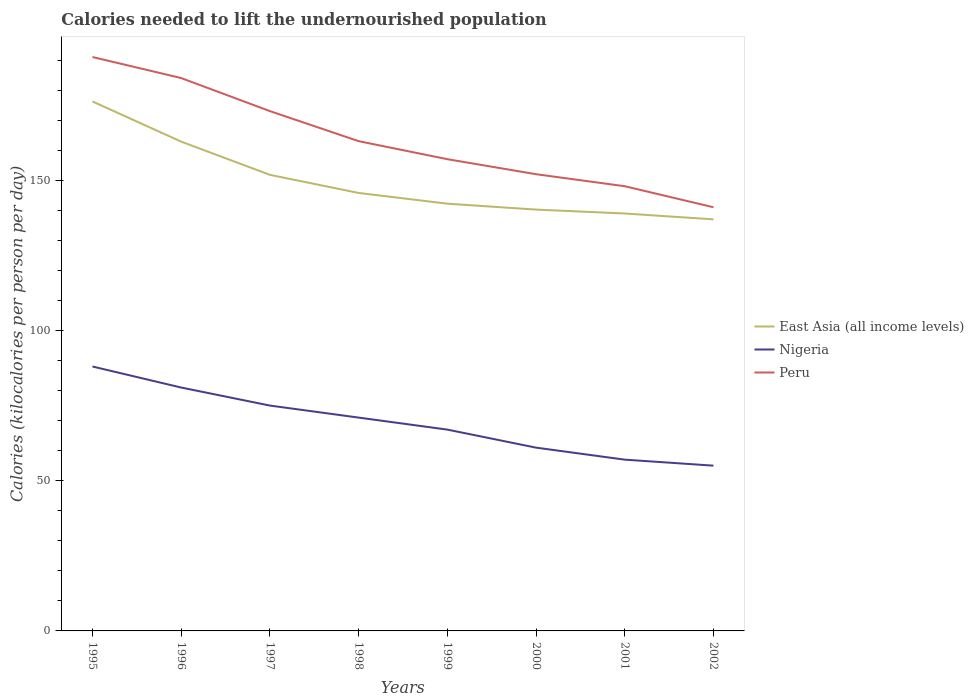How many different coloured lines are there?
Your answer should be compact. 3. Does the line corresponding to Peru intersect with the line corresponding to East Asia (all income levels)?
Provide a short and direct response. No. Across all years, what is the maximum total calories needed to lift the undernourished population in East Asia (all income levels)?
Keep it short and to the point. 136.97. What is the total total calories needed to lift the undernourished population in East Asia (all income levels) in the graph?
Your answer should be very brief. 3.25. What is the difference between the highest and the second highest total calories needed to lift the undernourished population in Nigeria?
Make the answer very short. 33. Is the total calories needed to lift the undernourished population in Nigeria strictly greater than the total calories needed to lift the undernourished population in East Asia (all income levels) over the years?
Offer a terse response. Yes. How many lines are there?
Your response must be concise. 3. How many years are there in the graph?
Make the answer very short. 8. Are the values on the major ticks of Y-axis written in scientific E-notation?
Provide a succinct answer. No. Does the graph contain grids?
Provide a short and direct response. No. How many legend labels are there?
Provide a short and direct response. 3. How are the legend labels stacked?
Provide a succinct answer. Vertical. What is the title of the graph?
Provide a short and direct response. Calories needed to lift the undernourished population. Does "Yemen, Rep." appear as one of the legend labels in the graph?
Your answer should be very brief. No. What is the label or title of the X-axis?
Keep it short and to the point. Years. What is the label or title of the Y-axis?
Give a very brief answer. Calories (kilocalories per person per day). What is the Calories (kilocalories per person per day) of East Asia (all income levels) in 1995?
Ensure brevity in your answer.  176.22. What is the Calories (kilocalories per person per day) in Peru in 1995?
Give a very brief answer. 191. What is the Calories (kilocalories per person per day) of East Asia (all income levels) in 1996?
Offer a terse response. 162.84. What is the Calories (kilocalories per person per day) of Nigeria in 1996?
Offer a very short reply. 81. What is the Calories (kilocalories per person per day) of Peru in 1996?
Provide a succinct answer. 184. What is the Calories (kilocalories per person per day) in East Asia (all income levels) in 1997?
Your answer should be very brief. 151.79. What is the Calories (kilocalories per person per day) in Nigeria in 1997?
Make the answer very short. 75. What is the Calories (kilocalories per person per day) in Peru in 1997?
Make the answer very short. 173. What is the Calories (kilocalories per person per day) of East Asia (all income levels) in 1998?
Provide a succinct answer. 145.76. What is the Calories (kilocalories per person per day) of Nigeria in 1998?
Your answer should be very brief. 71. What is the Calories (kilocalories per person per day) of Peru in 1998?
Your answer should be compact. 163. What is the Calories (kilocalories per person per day) of East Asia (all income levels) in 1999?
Give a very brief answer. 142.19. What is the Calories (kilocalories per person per day) of Peru in 1999?
Your answer should be very brief. 157. What is the Calories (kilocalories per person per day) of East Asia (all income levels) in 2000?
Offer a very short reply. 140.22. What is the Calories (kilocalories per person per day) in Nigeria in 2000?
Ensure brevity in your answer.  61. What is the Calories (kilocalories per person per day) of Peru in 2000?
Give a very brief answer. 152. What is the Calories (kilocalories per person per day) in East Asia (all income levels) in 2001?
Give a very brief answer. 138.92. What is the Calories (kilocalories per person per day) in Nigeria in 2001?
Offer a terse response. 57. What is the Calories (kilocalories per person per day) of Peru in 2001?
Make the answer very short. 148. What is the Calories (kilocalories per person per day) in East Asia (all income levels) in 2002?
Offer a very short reply. 136.97. What is the Calories (kilocalories per person per day) in Nigeria in 2002?
Provide a succinct answer. 55. What is the Calories (kilocalories per person per day) in Peru in 2002?
Offer a terse response. 141. Across all years, what is the maximum Calories (kilocalories per person per day) of East Asia (all income levels)?
Keep it short and to the point. 176.22. Across all years, what is the maximum Calories (kilocalories per person per day) in Peru?
Ensure brevity in your answer.  191. Across all years, what is the minimum Calories (kilocalories per person per day) in East Asia (all income levels)?
Provide a succinct answer. 136.97. Across all years, what is the minimum Calories (kilocalories per person per day) of Nigeria?
Provide a succinct answer. 55. Across all years, what is the minimum Calories (kilocalories per person per day) in Peru?
Your answer should be compact. 141. What is the total Calories (kilocalories per person per day) of East Asia (all income levels) in the graph?
Your answer should be compact. 1194.91. What is the total Calories (kilocalories per person per day) in Nigeria in the graph?
Offer a terse response. 555. What is the total Calories (kilocalories per person per day) of Peru in the graph?
Provide a short and direct response. 1309. What is the difference between the Calories (kilocalories per person per day) in East Asia (all income levels) in 1995 and that in 1996?
Make the answer very short. 13.38. What is the difference between the Calories (kilocalories per person per day) in Nigeria in 1995 and that in 1996?
Provide a succinct answer. 7. What is the difference between the Calories (kilocalories per person per day) of Peru in 1995 and that in 1996?
Make the answer very short. 7. What is the difference between the Calories (kilocalories per person per day) of East Asia (all income levels) in 1995 and that in 1997?
Your response must be concise. 24.43. What is the difference between the Calories (kilocalories per person per day) of East Asia (all income levels) in 1995 and that in 1998?
Offer a very short reply. 30.46. What is the difference between the Calories (kilocalories per person per day) of East Asia (all income levels) in 1995 and that in 1999?
Your answer should be very brief. 34.03. What is the difference between the Calories (kilocalories per person per day) in Nigeria in 1995 and that in 1999?
Your answer should be compact. 21. What is the difference between the Calories (kilocalories per person per day) of Peru in 1995 and that in 1999?
Keep it short and to the point. 34. What is the difference between the Calories (kilocalories per person per day) in East Asia (all income levels) in 1995 and that in 2000?
Keep it short and to the point. 36. What is the difference between the Calories (kilocalories per person per day) of Nigeria in 1995 and that in 2000?
Make the answer very short. 27. What is the difference between the Calories (kilocalories per person per day) of East Asia (all income levels) in 1995 and that in 2001?
Offer a very short reply. 37.29. What is the difference between the Calories (kilocalories per person per day) in Peru in 1995 and that in 2001?
Provide a succinct answer. 43. What is the difference between the Calories (kilocalories per person per day) of East Asia (all income levels) in 1995 and that in 2002?
Provide a succinct answer. 39.25. What is the difference between the Calories (kilocalories per person per day) of Nigeria in 1995 and that in 2002?
Provide a short and direct response. 33. What is the difference between the Calories (kilocalories per person per day) in Peru in 1995 and that in 2002?
Make the answer very short. 50. What is the difference between the Calories (kilocalories per person per day) in East Asia (all income levels) in 1996 and that in 1997?
Offer a terse response. 11.05. What is the difference between the Calories (kilocalories per person per day) of Nigeria in 1996 and that in 1997?
Provide a succinct answer. 6. What is the difference between the Calories (kilocalories per person per day) of Peru in 1996 and that in 1997?
Offer a very short reply. 11. What is the difference between the Calories (kilocalories per person per day) in East Asia (all income levels) in 1996 and that in 1998?
Offer a terse response. 17.08. What is the difference between the Calories (kilocalories per person per day) of East Asia (all income levels) in 1996 and that in 1999?
Provide a succinct answer. 20.65. What is the difference between the Calories (kilocalories per person per day) in Nigeria in 1996 and that in 1999?
Keep it short and to the point. 14. What is the difference between the Calories (kilocalories per person per day) in East Asia (all income levels) in 1996 and that in 2000?
Make the answer very short. 22.62. What is the difference between the Calories (kilocalories per person per day) of Nigeria in 1996 and that in 2000?
Your answer should be very brief. 20. What is the difference between the Calories (kilocalories per person per day) of East Asia (all income levels) in 1996 and that in 2001?
Your answer should be compact. 23.92. What is the difference between the Calories (kilocalories per person per day) of Peru in 1996 and that in 2001?
Provide a short and direct response. 36. What is the difference between the Calories (kilocalories per person per day) of East Asia (all income levels) in 1996 and that in 2002?
Your answer should be very brief. 25.87. What is the difference between the Calories (kilocalories per person per day) of East Asia (all income levels) in 1997 and that in 1998?
Make the answer very short. 6.03. What is the difference between the Calories (kilocalories per person per day) of Nigeria in 1997 and that in 1998?
Your response must be concise. 4. What is the difference between the Calories (kilocalories per person per day) in Peru in 1997 and that in 1998?
Offer a terse response. 10. What is the difference between the Calories (kilocalories per person per day) of East Asia (all income levels) in 1997 and that in 1999?
Your answer should be compact. 9.6. What is the difference between the Calories (kilocalories per person per day) in Nigeria in 1997 and that in 1999?
Your answer should be very brief. 8. What is the difference between the Calories (kilocalories per person per day) in Peru in 1997 and that in 1999?
Offer a very short reply. 16. What is the difference between the Calories (kilocalories per person per day) in East Asia (all income levels) in 1997 and that in 2000?
Keep it short and to the point. 11.57. What is the difference between the Calories (kilocalories per person per day) of Nigeria in 1997 and that in 2000?
Offer a terse response. 14. What is the difference between the Calories (kilocalories per person per day) in Peru in 1997 and that in 2000?
Your answer should be compact. 21. What is the difference between the Calories (kilocalories per person per day) in East Asia (all income levels) in 1997 and that in 2001?
Offer a terse response. 12.86. What is the difference between the Calories (kilocalories per person per day) of East Asia (all income levels) in 1997 and that in 2002?
Your answer should be very brief. 14.82. What is the difference between the Calories (kilocalories per person per day) in Nigeria in 1997 and that in 2002?
Provide a succinct answer. 20. What is the difference between the Calories (kilocalories per person per day) of East Asia (all income levels) in 1998 and that in 1999?
Provide a succinct answer. 3.57. What is the difference between the Calories (kilocalories per person per day) in Peru in 1998 and that in 1999?
Ensure brevity in your answer.  6. What is the difference between the Calories (kilocalories per person per day) in East Asia (all income levels) in 1998 and that in 2000?
Make the answer very short. 5.54. What is the difference between the Calories (kilocalories per person per day) in East Asia (all income levels) in 1998 and that in 2001?
Your response must be concise. 6.83. What is the difference between the Calories (kilocalories per person per day) in East Asia (all income levels) in 1998 and that in 2002?
Provide a short and direct response. 8.79. What is the difference between the Calories (kilocalories per person per day) of East Asia (all income levels) in 1999 and that in 2000?
Offer a terse response. 1.97. What is the difference between the Calories (kilocalories per person per day) of Nigeria in 1999 and that in 2000?
Your answer should be very brief. 6. What is the difference between the Calories (kilocalories per person per day) of Peru in 1999 and that in 2000?
Your answer should be compact. 5. What is the difference between the Calories (kilocalories per person per day) in East Asia (all income levels) in 1999 and that in 2001?
Make the answer very short. 3.27. What is the difference between the Calories (kilocalories per person per day) of Nigeria in 1999 and that in 2001?
Provide a succinct answer. 10. What is the difference between the Calories (kilocalories per person per day) in East Asia (all income levels) in 1999 and that in 2002?
Your answer should be very brief. 5.22. What is the difference between the Calories (kilocalories per person per day) in East Asia (all income levels) in 2000 and that in 2001?
Your response must be concise. 1.29. What is the difference between the Calories (kilocalories per person per day) in Peru in 2000 and that in 2001?
Offer a very short reply. 4. What is the difference between the Calories (kilocalories per person per day) of East Asia (all income levels) in 2000 and that in 2002?
Keep it short and to the point. 3.25. What is the difference between the Calories (kilocalories per person per day) in East Asia (all income levels) in 2001 and that in 2002?
Offer a very short reply. 1.95. What is the difference between the Calories (kilocalories per person per day) in East Asia (all income levels) in 1995 and the Calories (kilocalories per person per day) in Nigeria in 1996?
Make the answer very short. 95.22. What is the difference between the Calories (kilocalories per person per day) in East Asia (all income levels) in 1995 and the Calories (kilocalories per person per day) in Peru in 1996?
Offer a terse response. -7.78. What is the difference between the Calories (kilocalories per person per day) in Nigeria in 1995 and the Calories (kilocalories per person per day) in Peru in 1996?
Ensure brevity in your answer.  -96. What is the difference between the Calories (kilocalories per person per day) of East Asia (all income levels) in 1995 and the Calories (kilocalories per person per day) of Nigeria in 1997?
Give a very brief answer. 101.22. What is the difference between the Calories (kilocalories per person per day) in East Asia (all income levels) in 1995 and the Calories (kilocalories per person per day) in Peru in 1997?
Keep it short and to the point. 3.22. What is the difference between the Calories (kilocalories per person per day) in Nigeria in 1995 and the Calories (kilocalories per person per day) in Peru in 1997?
Provide a succinct answer. -85. What is the difference between the Calories (kilocalories per person per day) of East Asia (all income levels) in 1995 and the Calories (kilocalories per person per day) of Nigeria in 1998?
Your response must be concise. 105.22. What is the difference between the Calories (kilocalories per person per day) of East Asia (all income levels) in 1995 and the Calories (kilocalories per person per day) of Peru in 1998?
Give a very brief answer. 13.22. What is the difference between the Calories (kilocalories per person per day) in Nigeria in 1995 and the Calories (kilocalories per person per day) in Peru in 1998?
Offer a terse response. -75. What is the difference between the Calories (kilocalories per person per day) of East Asia (all income levels) in 1995 and the Calories (kilocalories per person per day) of Nigeria in 1999?
Your answer should be very brief. 109.22. What is the difference between the Calories (kilocalories per person per day) of East Asia (all income levels) in 1995 and the Calories (kilocalories per person per day) of Peru in 1999?
Offer a very short reply. 19.22. What is the difference between the Calories (kilocalories per person per day) of Nigeria in 1995 and the Calories (kilocalories per person per day) of Peru in 1999?
Offer a terse response. -69. What is the difference between the Calories (kilocalories per person per day) of East Asia (all income levels) in 1995 and the Calories (kilocalories per person per day) of Nigeria in 2000?
Your answer should be very brief. 115.22. What is the difference between the Calories (kilocalories per person per day) in East Asia (all income levels) in 1995 and the Calories (kilocalories per person per day) in Peru in 2000?
Provide a succinct answer. 24.22. What is the difference between the Calories (kilocalories per person per day) in Nigeria in 1995 and the Calories (kilocalories per person per day) in Peru in 2000?
Provide a short and direct response. -64. What is the difference between the Calories (kilocalories per person per day) of East Asia (all income levels) in 1995 and the Calories (kilocalories per person per day) of Nigeria in 2001?
Your answer should be compact. 119.22. What is the difference between the Calories (kilocalories per person per day) of East Asia (all income levels) in 1995 and the Calories (kilocalories per person per day) of Peru in 2001?
Keep it short and to the point. 28.22. What is the difference between the Calories (kilocalories per person per day) of Nigeria in 1995 and the Calories (kilocalories per person per day) of Peru in 2001?
Ensure brevity in your answer.  -60. What is the difference between the Calories (kilocalories per person per day) in East Asia (all income levels) in 1995 and the Calories (kilocalories per person per day) in Nigeria in 2002?
Keep it short and to the point. 121.22. What is the difference between the Calories (kilocalories per person per day) of East Asia (all income levels) in 1995 and the Calories (kilocalories per person per day) of Peru in 2002?
Offer a very short reply. 35.22. What is the difference between the Calories (kilocalories per person per day) of Nigeria in 1995 and the Calories (kilocalories per person per day) of Peru in 2002?
Provide a succinct answer. -53. What is the difference between the Calories (kilocalories per person per day) in East Asia (all income levels) in 1996 and the Calories (kilocalories per person per day) in Nigeria in 1997?
Your response must be concise. 87.84. What is the difference between the Calories (kilocalories per person per day) in East Asia (all income levels) in 1996 and the Calories (kilocalories per person per day) in Peru in 1997?
Offer a very short reply. -10.16. What is the difference between the Calories (kilocalories per person per day) in Nigeria in 1996 and the Calories (kilocalories per person per day) in Peru in 1997?
Provide a short and direct response. -92. What is the difference between the Calories (kilocalories per person per day) of East Asia (all income levels) in 1996 and the Calories (kilocalories per person per day) of Nigeria in 1998?
Offer a terse response. 91.84. What is the difference between the Calories (kilocalories per person per day) in East Asia (all income levels) in 1996 and the Calories (kilocalories per person per day) in Peru in 1998?
Provide a short and direct response. -0.16. What is the difference between the Calories (kilocalories per person per day) of Nigeria in 1996 and the Calories (kilocalories per person per day) of Peru in 1998?
Your answer should be very brief. -82. What is the difference between the Calories (kilocalories per person per day) in East Asia (all income levels) in 1996 and the Calories (kilocalories per person per day) in Nigeria in 1999?
Your answer should be compact. 95.84. What is the difference between the Calories (kilocalories per person per day) in East Asia (all income levels) in 1996 and the Calories (kilocalories per person per day) in Peru in 1999?
Provide a short and direct response. 5.84. What is the difference between the Calories (kilocalories per person per day) in Nigeria in 1996 and the Calories (kilocalories per person per day) in Peru in 1999?
Your answer should be compact. -76. What is the difference between the Calories (kilocalories per person per day) in East Asia (all income levels) in 1996 and the Calories (kilocalories per person per day) in Nigeria in 2000?
Give a very brief answer. 101.84. What is the difference between the Calories (kilocalories per person per day) in East Asia (all income levels) in 1996 and the Calories (kilocalories per person per day) in Peru in 2000?
Ensure brevity in your answer.  10.84. What is the difference between the Calories (kilocalories per person per day) of Nigeria in 1996 and the Calories (kilocalories per person per day) of Peru in 2000?
Your answer should be very brief. -71. What is the difference between the Calories (kilocalories per person per day) in East Asia (all income levels) in 1996 and the Calories (kilocalories per person per day) in Nigeria in 2001?
Your answer should be very brief. 105.84. What is the difference between the Calories (kilocalories per person per day) of East Asia (all income levels) in 1996 and the Calories (kilocalories per person per day) of Peru in 2001?
Offer a very short reply. 14.84. What is the difference between the Calories (kilocalories per person per day) of Nigeria in 1996 and the Calories (kilocalories per person per day) of Peru in 2001?
Your answer should be very brief. -67. What is the difference between the Calories (kilocalories per person per day) of East Asia (all income levels) in 1996 and the Calories (kilocalories per person per day) of Nigeria in 2002?
Keep it short and to the point. 107.84. What is the difference between the Calories (kilocalories per person per day) in East Asia (all income levels) in 1996 and the Calories (kilocalories per person per day) in Peru in 2002?
Provide a short and direct response. 21.84. What is the difference between the Calories (kilocalories per person per day) of Nigeria in 1996 and the Calories (kilocalories per person per day) of Peru in 2002?
Give a very brief answer. -60. What is the difference between the Calories (kilocalories per person per day) in East Asia (all income levels) in 1997 and the Calories (kilocalories per person per day) in Nigeria in 1998?
Make the answer very short. 80.79. What is the difference between the Calories (kilocalories per person per day) in East Asia (all income levels) in 1997 and the Calories (kilocalories per person per day) in Peru in 1998?
Give a very brief answer. -11.21. What is the difference between the Calories (kilocalories per person per day) in Nigeria in 1997 and the Calories (kilocalories per person per day) in Peru in 1998?
Provide a short and direct response. -88. What is the difference between the Calories (kilocalories per person per day) in East Asia (all income levels) in 1997 and the Calories (kilocalories per person per day) in Nigeria in 1999?
Your response must be concise. 84.79. What is the difference between the Calories (kilocalories per person per day) in East Asia (all income levels) in 1997 and the Calories (kilocalories per person per day) in Peru in 1999?
Make the answer very short. -5.21. What is the difference between the Calories (kilocalories per person per day) in Nigeria in 1997 and the Calories (kilocalories per person per day) in Peru in 1999?
Make the answer very short. -82. What is the difference between the Calories (kilocalories per person per day) of East Asia (all income levels) in 1997 and the Calories (kilocalories per person per day) of Nigeria in 2000?
Keep it short and to the point. 90.79. What is the difference between the Calories (kilocalories per person per day) in East Asia (all income levels) in 1997 and the Calories (kilocalories per person per day) in Peru in 2000?
Offer a very short reply. -0.21. What is the difference between the Calories (kilocalories per person per day) of Nigeria in 1997 and the Calories (kilocalories per person per day) of Peru in 2000?
Your response must be concise. -77. What is the difference between the Calories (kilocalories per person per day) in East Asia (all income levels) in 1997 and the Calories (kilocalories per person per day) in Nigeria in 2001?
Provide a short and direct response. 94.79. What is the difference between the Calories (kilocalories per person per day) in East Asia (all income levels) in 1997 and the Calories (kilocalories per person per day) in Peru in 2001?
Give a very brief answer. 3.79. What is the difference between the Calories (kilocalories per person per day) in Nigeria in 1997 and the Calories (kilocalories per person per day) in Peru in 2001?
Make the answer very short. -73. What is the difference between the Calories (kilocalories per person per day) in East Asia (all income levels) in 1997 and the Calories (kilocalories per person per day) in Nigeria in 2002?
Keep it short and to the point. 96.79. What is the difference between the Calories (kilocalories per person per day) in East Asia (all income levels) in 1997 and the Calories (kilocalories per person per day) in Peru in 2002?
Offer a terse response. 10.79. What is the difference between the Calories (kilocalories per person per day) in Nigeria in 1997 and the Calories (kilocalories per person per day) in Peru in 2002?
Keep it short and to the point. -66. What is the difference between the Calories (kilocalories per person per day) of East Asia (all income levels) in 1998 and the Calories (kilocalories per person per day) of Nigeria in 1999?
Your answer should be compact. 78.76. What is the difference between the Calories (kilocalories per person per day) in East Asia (all income levels) in 1998 and the Calories (kilocalories per person per day) in Peru in 1999?
Make the answer very short. -11.24. What is the difference between the Calories (kilocalories per person per day) in Nigeria in 1998 and the Calories (kilocalories per person per day) in Peru in 1999?
Make the answer very short. -86. What is the difference between the Calories (kilocalories per person per day) of East Asia (all income levels) in 1998 and the Calories (kilocalories per person per day) of Nigeria in 2000?
Your answer should be compact. 84.76. What is the difference between the Calories (kilocalories per person per day) in East Asia (all income levels) in 1998 and the Calories (kilocalories per person per day) in Peru in 2000?
Make the answer very short. -6.24. What is the difference between the Calories (kilocalories per person per day) in Nigeria in 1998 and the Calories (kilocalories per person per day) in Peru in 2000?
Your answer should be compact. -81. What is the difference between the Calories (kilocalories per person per day) in East Asia (all income levels) in 1998 and the Calories (kilocalories per person per day) in Nigeria in 2001?
Provide a succinct answer. 88.76. What is the difference between the Calories (kilocalories per person per day) of East Asia (all income levels) in 1998 and the Calories (kilocalories per person per day) of Peru in 2001?
Ensure brevity in your answer.  -2.24. What is the difference between the Calories (kilocalories per person per day) in Nigeria in 1998 and the Calories (kilocalories per person per day) in Peru in 2001?
Your answer should be very brief. -77. What is the difference between the Calories (kilocalories per person per day) in East Asia (all income levels) in 1998 and the Calories (kilocalories per person per day) in Nigeria in 2002?
Your answer should be compact. 90.76. What is the difference between the Calories (kilocalories per person per day) of East Asia (all income levels) in 1998 and the Calories (kilocalories per person per day) of Peru in 2002?
Provide a short and direct response. 4.76. What is the difference between the Calories (kilocalories per person per day) in Nigeria in 1998 and the Calories (kilocalories per person per day) in Peru in 2002?
Keep it short and to the point. -70. What is the difference between the Calories (kilocalories per person per day) of East Asia (all income levels) in 1999 and the Calories (kilocalories per person per day) of Nigeria in 2000?
Give a very brief answer. 81.19. What is the difference between the Calories (kilocalories per person per day) of East Asia (all income levels) in 1999 and the Calories (kilocalories per person per day) of Peru in 2000?
Offer a very short reply. -9.81. What is the difference between the Calories (kilocalories per person per day) in Nigeria in 1999 and the Calories (kilocalories per person per day) in Peru in 2000?
Make the answer very short. -85. What is the difference between the Calories (kilocalories per person per day) in East Asia (all income levels) in 1999 and the Calories (kilocalories per person per day) in Nigeria in 2001?
Ensure brevity in your answer.  85.19. What is the difference between the Calories (kilocalories per person per day) in East Asia (all income levels) in 1999 and the Calories (kilocalories per person per day) in Peru in 2001?
Your answer should be very brief. -5.81. What is the difference between the Calories (kilocalories per person per day) in Nigeria in 1999 and the Calories (kilocalories per person per day) in Peru in 2001?
Your response must be concise. -81. What is the difference between the Calories (kilocalories per person per day) in East Asia (all income levels) in 1999 and the Calories (kilocalories per person per day) in Nigeria in 2002?
Give a very brief answer. 87.19. What is the difference between the Calories (kilocalories per person per day) of East Asia (all income levels) in 1999 and the Calories (kilocalories per person per day) of Peru in 2002?
Your answer should be very brief. 1.19. What is the difference between the Calories (kilocalories per person per day) of Nigeria in 1999 and the Calories (kilocalories per person per day) of Peru in 2002?
Make the answer very short. -74. What is the difference between the Calories (kilocalories per person per day) of East Asia (all income levels) in 2000 and the Calories (kilocalories per person per day) of Nigeria in 2001?
Keep it short and to the point. 83.22. What is the difference between the Calories (kilocalories per person per day) of East Asia (all income levels) in 2000 and the Calories (kilocalories per person per day) of Peru in 2001?
Your response must be concise. -7.78. What is the difference between the Calories (kilocalories per person per day) of Nigeria in 2000 and the Calories (kilocalories per person per day) of Peru in 2001?
Provide a succinct answer. -87. What is the difference between the Calories (kilocalories per person per day) of East Asia (all income levels) in 2000 and the Calories (kilocalories per person per day) of Nigeria in 2002?
Your response must be concise. 85.22. What is the difference between the Calories (kilocalories per person per day) in East Asia (all income levels) in 2000 and the Calories (kilocalories per person per day) in Peru in 2002?
Offer a very short reply. -0.78. What is the difference between the Calories (kilocalories per person per day) in Nigeria in 2000 and the Calories (kilocalories per person per day) in Peru in 2002?
Your answer should be compact. -80. What is the difference between the Calories (kilocalories per person per day) in East Asia (all income levels) in 2001 and the Calories (kilocalories per person per day) in Nigeria in 2002?
Offer a very short reply. 83.92. What is the difference between the Calories (kilocalories per person per day) of East Asia (all income levels) in 2001 and the Calories (kilocalories per person per day) of Peru in 2002?
Ensure brevity in your answer.  -2.08. What is the difference between the Calories (kilocalories per person per day) in Nigeria in 2001 and the Calories (kilocalories per person per day) in Peru in 2002?
Your answer should be very brief. -84. What is the average Calories (kilocalories per person per day) of East Asia (all income levels) per year?
Provide a short and direct response. 149.36. What is the average Calories (kilocalories per person per day) in Nigeria per year?
Offer a terse response. 69.38. What is the average Calories (kilocalories per person per day) in Peru per year?
Offer a terse response. 163.62. In the year 1995, what is the difference between the Calories (kilocalories per person per day) in East Asia (all income levels) and Calories (kilocalories per person per day) in Nigeria?
Offer a very short reply. 88.22. In the year 1995, what is the difference between the Calories (kilocalories per person per day) in East Asia (all income levels) and Calories (kilocalories per person per day) in Peru?
Provide a short and direct response. -14.78. In the year 1995, what is the difference between the Calories (kilocalories per person per day) in Nigeria and Calories (kilocalories per person per day) in Peru?
Make the answer very short. -103. In the year 1996, what is the difference between the Calories (kilocalories per person per day) in East Asia (all income levels) and Calories (kilocalories per person per day) in Nigeria?
Your answer should be very brief. 81.84. In the year 1996, what is the difference between the Calories (kilocalories per person per day) of East Asia (all income levels) and Calories (kilocalories per person per day) of Peru?
Ensure brevity in your answer.  -21.16. In the year 1996, what is the difference between the Calories (kilocalories per person per day) of Nigeria and Calories (kilocalories per person per day) of Peru?
Give a very brief answer. -103. In the year 1997, what is the difference between the Calories (kilocalories per person per day) in East Asia (all income levels) and Calories (kilocalories per person per day) in Nigeria?
Provide a short and direct response. 76.79. In the year 1997, what is the difference between the Calories (kilocalories per person per day) of East Asia (all income levels) and Calories (kilocalories per person per day) of Peru?
Offer a terse response. -21.21. In the year 1997, what is the difference between the Calories (kilocalories per person per day) of Nigeria and Calories (kilocalories per person per day) of Peru?
Give a very brief answer. -98. In the year 1998, what is the difference between the Calories (kilocalories per person per day) in East Asia (all income levels) and Calories (kilocalories per person per day) in Nigeria?
Provide a short and direct response. 74.76. In the year 1998, what is the difference between the Calories (kilocalories per person per day) of East Asia (all income levels) and Calories (kilocalories per person per day) of Peru?
Make the answer very short. -17.24. In the year 1998, what is the difference between the Calories (kilocalories per person per day) in Nigeria and Calories (kilocalories per person per day) in Peru?
Your answer should be compact. -92. In the year 1999, what is the difference between the Calories (kilocalories per person per day) of East Asia (all income levels) and Calories (kilocalories per person per day) of Nigeria?
Make the answer very short. 75.19. In the year 1999, what is the difference between the Calories (kilocalories per person per day) of East Asia (all income levels) and Calories (kilocalories per person per day) of Peru?
Keep it short and to the point. -14.81. In the year 1999, what is the difference between the Calories (kilocalories per person per day) of Nigeria and Calories (kilocalories per person per day) of Peru?
Offer a terse response. -90. In the year 2000, what is the difference between the Calories (kilocalories per person per day) in East Asia (all income levels) and Calories (kilocalories per person per day) in Nigeria?
Your answer should be compact. 79.22. In the year 2000, what is the difference between the Calories (kilocalories per person per day) in East Asia (all income levels) and Calories (kilocalories per person per day) in Peru?
Provide a succinct answer. -11.78. In the year 2000, what is the difference between the Calories (kilocalories per person per day) of Nigeria and Calories (kilocalories per person per day) of Peru?
Keep it short and to the point. -91. In the year 2001, what is the difference between the Calories (kilocalories per person per day) of East Asia (all income levels) and Calories (kilocalories per person per day) of Nigeria?
Offer a terse response. 81.92. In the year 2001, what is the difference between the Calories (kilocalories per person per day) of East Asia (all income levels) and Calories (kilocalories per person per day) of Peru?
Your response must be concise. -9.08. In the year 2001, what is the difference between the Calories (kilocalories per person per day) of Nigeria and Calories (kilocalories per person per day) of Peru?
Provide a short and direct response. -91. In the year 2002, what is the difference between the Calories (kilocalories per person per day) in East Asia (all income levels) and Calories (kilocalories per person per day) in Nigeria?
Your response must be concise. 81.97. In the year 2002, what is the difference between the Calories (kilocalories per person per day) in East Asia (all income levels) and Calories (kilocalories per person per day) in Peru?
Offer a terse response. -4.03. In the year 2002, what is the difference between the Calories (kilocalories per person per day) in Nigeria and Calories (kilocalories per person per day) in Peru?
Make the answer very short. -86. What is the ratio of the Calories (kilocalories per person per day) in East Asia (all income levels) in 1995 to that in 1996?
Your answer should be compact. 1.08. What is the ratio of the Calories (kilocalories per person per day) in Nigeria in 1995 to that in 1996?
Offer a very short reply. 1.09. What is the ratio of the Calories (kilocalories per person per day) of Peru in 1995 to that in 1996?
Provide a succinct answer. 1.04. What is the ratio of the Calories (kilocalories per person per day) of East Asia (all income levels) in 1995 to that in 1997?
Offer a terse response. 1.16. What is the ratio of the Calories (kilocalories per person per day) in Nigeria in 1995 to that in 1997?
Your response must be concise. 1.17. What is the ratio of the Calories (kilocalories per person per day) of Peru in 1995 to that in 1997?
Provide a short and direct response. 1.1. What is the ratio of the Calories (kilocalories per person per day) of East Asia (all income levels) in 1995 to that in 1998?
Make the answer very short. 1.21. What is the ratio of the Calories (kilocalories per person per day) in Nigeria in 1995 to that in 1998?
Keep it short and to the point. 1.24. What is the ratio of the Calories (kilocalories per person per day) of Peru in 1995 to that in 1998?
Make the answer very short. 1.17. What is the ratio of the Calories (kilocalories per person per day) of East Asia (all income levels) in 1995 to that in 1999?
Give a very brief answer. 1.24. What is the ratio of the Calories (kilocalories per person per day) in Nigeria in 1995 to that in 1999?
Ensure brevity in your answer.  1.31. What is the ratio of the Calories (kilocalories per person per day) of Peru in 1995 to that in 1999?
Offer a very short reply. 1.22. What is the ratio of the Calories (kilocalories per person per day) of East Asia (all income levels) in 1995 to that in 2000?
Your answer should be very brief. 1.26. What is the ratio of the Calories (kilocalories per person per day) of Nigeria in 1995 to that in 2000?
Make the answer very short. 1.44. What is the ratio of the Calories (kilocalories per person per day) in Peru in 1995 to that in 2000?
Your response must be concise. 1.26. What is the ratio of the Calories (kilocalories per person per day) in East Asia (all income levels) in 1995 to that in 2001?
Your response must be concise. 1.27. What is the ratio of the Calories (kilocalories per person per day) of Nigeria in 1995 to that in 2001?
Provide a short and direct response. 1.54. What is the ratio of the Calories (kilocalories per person per day) of Peru in 1995 to that in 2001?
Your answer should be very brief. 1.29. What is the ratio of the Calories (kilocalories per person per day) in East Asia (all income levels) in 1995 to that in 2002?
Your response must be concise. 1.29. What is the ratio of the Calories (kilocalories per person per day) in Peru in 1995 to that in 2002?
Provide a short and direct response. 1.35. What is the ratio of the Calories (kilocalories per person per day) of East Asia (all income levels) in 1996 to that in 1997?
Your response must be concise. 1.07. What is the ratio of the Calories (kilocalories per person per day) in Nigeria in 1996 to that in 1997?
Provide a succinct answer. 1.08. What is the ratio of the Calories (kilocalories per person per day) of Peru in 1996 to that in 1997?
Ensure brevity in your answer.  1.06. What is the ratio of the Calories (kilocalories per person per day) in East Asia (all income levels) in 1996 to that in 1998?
Offer a very short reply. 1.12. What is the ratio of the Calories (kilocalories per person per day) of Nigeria in 1996 to that in 1998?
Provide a short and direct response. 1.14. What is the ratio of the Calories (kilocalories per person per day) in Peru in 1996 to that in 1998?
Offer a very short reply. 1.13. What is the ratio of the Calories (kilocalories per person per day) in East Asia (all income levels) in 1996 to that in 1999?
Provide a short and direct response. 1.15. What is the ratio of the Calories (kilocalories per person per day) in Nigeria in 1996 to that in 1999?
Your answer should be very brief. 1.21. What is the ratio of the Calories (kilocalories per person per day) of Peru in 1996 to that in 1999?
Keep it short and to the point. 1.17. What is the ratio of the Calories (kilocalories per person per day) in East Asia (all income levels) in 1996 to that in 2000?
Provide a short and direct response. 1.16. What is the ratio of the Calories (kilocalories per person per day) of Nigeria in 1996 to that in 2000?
Provide a succinct answer. 1.33. What is the ratio of the Calories (kilocalories per person per day) of Peru in 1996 to that in 2000?
Make the answer very short. 1.21. What is the ratio of the Calories (kilocalories per person per day) of East Asia (all income levels) in 1996 to that in 2001?
Make the answer very short. 1.17. What is the ratio of the Calories (kilocalories per person per day) of Nigeria in 1996 to that in 2001?
Ensure brevity in your answer.  1.42. What is the ratio of the Calories (kilocalories per person per day) in Peru in 1996 to that in 2001?
Ensure brevity in your answer.  1.24. What is the ratio of the Calories (kilocalories per person per day) of East Asia (all income levels) in 1996 to that in 2002?
Offer a terse response. 1.19. What is the ratio of the Calories (kilocalories per person per day) of Nigeria in 1996 to that in 2002?
Provide a succinct answer. 1.47. What is the ratio of the Calories (kilocalories per person per day) of Peru in 1996 to that in 2002?
Make the answer very short. 1.3. What is the ratio of the Calories (kilocalories per person per day) in East Asia (all income levels) in 1997 to that in 1998?
Your response must be concise. 1.04. What is the ratio of the Calories (kilocalories per person per day) in Nigeria in 1997 to that in 1998?
Keep it short and to the point. 1.06. What is the ratio of the Calories (kilocalories per person per day) in Peru in 1997 to that in 1998?
Offer a terse response. 1.06. What is the ratio of the Calories (kilocalories per person per day) of East Asia (all income levels) in 1997 to that in 1999?
Your answer should be compact. 1.07. What is the ratio of the Calories (kilocalories per person per day) in Nigeria in 1997 to that in 1999?
Offer a terse response. 1.12. What is the ratio of the Calories (kilocalories per person per day) in Peru in 1997 to that in 1999?
Offer a terse response. 1.1. What is the ratio of the Calories (kilocalories per person per day) in East Asia (all income levels) in 1997 to that in 2000?
Offer a terse response. 1.08. What is the ratio of the Calories (kilocalories per person per day) of Nigeria in 1997 to that in 2000?
Offer a very short reply. 1.23. What is the ratio of the Calories (kilocalories per person per day) of Peru in 1997 to that in 2000?
Keep it short and to the point. 1.14. What is the ratio of the Calories (kilocalories per person per day) in East Asia (all income levels) in 1997 to that in 2001?
Your response must be concise. 1.09. What is the ratio of the Calories (kilocalories per person per day) in Nigeria in 1997 to that in 2001?
Ensure brevity in your answer.  1.32. What is the ratio of the Calories (kilocalories per person per day) of Peru in 1997 to that in 2001?
Make the answer very short. 1.17. What is the ratio of the Calories (kilocalories per person per day) of East Asia (all income levels) in 1997 to that in 2002?
Your answer should be compact. 1.11. What is the ratio of the Calories (kilocalories per person per day) of Nigeria in 1997 to that in 2002?
Give a very brief answer. 1.36. What is the ratio of the Calories (kilocalories per person per day) in Peru in 1997 to that in 2002?
Offer a terse response. 1.23. What is the ratio of the Calories (kilocalories per person per day) of East Asia (all income levels) in 1998 to that in 1999?
Ensure brevity in your answer.  1.03. What is the ratio of the Calories (kilocalories per person per day) in Nigeria in 1998 to that in 1999?
Offer a very short reply. 1.06. What is the ratio of the Calories (kilocalories per person per day) of Peru in 1998 to that in 1999?
Offer a very short reply. 1.04. What is the ratio of the Calories (kilocalories per person per day) of East Asia (all income levels) in 1998 to that in 2000?
Your response must be concise. 1.04. What is the ratio of the Calories (kilocalories per person per day) of Nigeria in 1998 to that in 2000?
Give a very brief answer. 1.16. What is the ratio of the Calories (kilocalories per person per day) of Peru in 1998 to that in 2000?
Offer a very short reply. 1.07. What is the ratio of the Calories (kilocalories per person per day) of East Asia (all income levels) in 1998 to that in 2001?
Offer a very short reply. 1.05. What is the ratio of the Calories (kilocalories per person per day) in Nigeria in 1998 to that in 2001?
Provide a succinct answer. 1.25. What is the ratio of the Calories (kilocalories per person per day) in Peru in 1998 to that in 2001?
Give a very brief answer. 1.1. What is the ratio of the Calories (kilocalories per person per day) of East Asia (all income levels) in 1998 to that in 2002?
Offer a terse response. 1.06. What is the ratio of the Calories (kilocalories per person per day) of Nigeria in 1998 to that in 2002?
Provide a short and direct response. 1.29. What is the ratio of the Calories (kilocalories per person per day) of Peru in 1998 to that in 2002?
Your answer should be compact. 1.16. What is the ratio of the Calories (kilocalories per person per day) in East Asia (all income levels) in 1999 to that in 2000?
Ensure brevity in your answer.  1.01. What is the ratio of the Calories (kilocalories per person per day) in Nigeria in 1999 to that in 2000?
Your response must be concise. 1.1. What is the ratio of the Calories (kilocalories per person per day) of Peru in 1999 to that in 2000?
Provide a succinct answer. 1.03. What is the ratio of the Calories (kilocalories per person per day) in East Asia (all income levels) in 1999 to that in 2001?
Keep it short and to the point. 1.02. What is the ratio of the Calories (kilocalories per person per day) in Nigeria in 1999 to that in 2001?
Offer a very short reply. 1.18. What is the ratio of the Calories (kilocalories per person per day) of Peru in 1999 to that in 2001?
Your response must be concise. 1.06. What is the ratio of the Calories (kilocalories per person per day) of East Asia (all income levels) in 1999 to that in 2002?
Your response must be concise. 1.04. What is the ratio of the Calories (kilocalories per person per day) of Nigeria in 1999 to that in 2002?
Keep it short and to the point. 1.22. What is the ratio of the Calories (kilocalories per person per day) in Peru in 1999 to that in 2002?
Provide a short and direct response. 1.11. What is the ratio of the Calories (kilocalories per person per day) in East Asia (all income levels) in 2000 to that in 2001?
Your answer should be very brief. 1.01. What is the ratio of the Calories (kilocalories per person per day) of Nigeria in 2000 to that in 2001?
Your answer should be very brief. 1.07. What is the ratio of the Calories (kilocalories per person per day) in Peru in 2000 to that in 2001?
Offer a very short reply. 1.03. What is the ratio of the Calories (kilocalories per person per day) in East Asia (all income levels) in 2000 to that in 2002?
Offer a terse response. 1.02. What is the ratio of the Calories (kilocalories per person per day) in Nigeria in 2000 to that in 2002?
Give a very brief answer. 1.11. What is the ratio of the Calories (kilocalories per person per day) of Peru in 2000 to that in 2002?
Give a very brief answer. 1.08. What is the ratio of the Calories (kilocalories per person per day) in East Asia (all income levels) in 2001 to that in 2002?
Your answer should be very brief. 1.01. What is the ratio of the Calories (kilocalories per person per day) in Nigeria in 2001 to that in 2002?
Give a very brief answer. 1.04. What is the ratio of the Calories (kilocalories per person per day) of Peru in 2001 to that in 2002?
Give a very brief answer. 1.05. What is the difference between the highest and the second highest Calories (kilocalories per person per day) in East Asia (all income levels)?
Ensure brevity in your answer.  13.38. What is the difference between the highest and the second highest Calories (kilocalories per person per day) of Nigeria?
Your response must be concise. 7. What is the difference between the highest and the second highest Calories (kilocalories per person per day) of Peru?
Your answer should be compact. 7. What is the difference between the highest and the lowest Calories (kilocalories per person per day) of East Asia (all income levels)?
Provide a succinct answer. 39.25. What is the difference between the highest and the lowest Calories (kilocalories per person per day) of Peru?
Offer a very short reply. 50. 